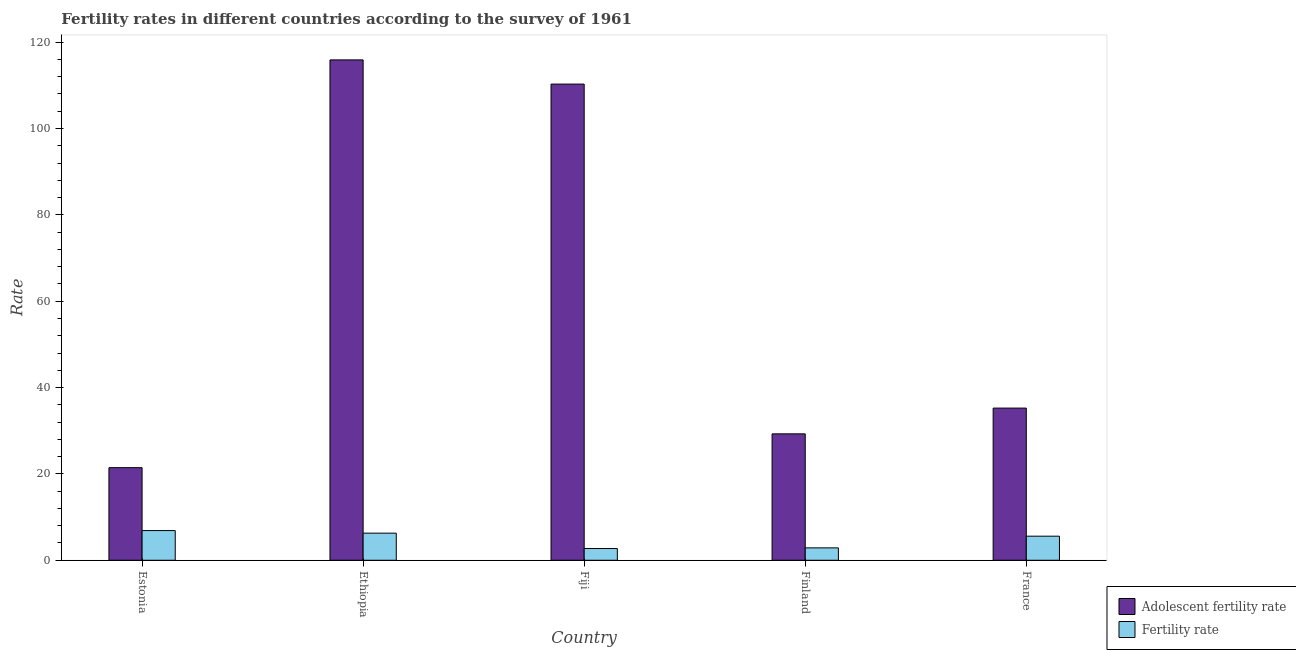How many different coloured bars are there?
Provide a succinct answer. 2. How many groups of bars are there?
Provide a short and direct response. 5. Are the number of bars on each tick of the X-axis equal?
Make the answer very short. Yes. What is the label of the 4th group of bars from the left?
Ensure brevity in your answer.  Finland. What is the fertility rate in France?
Provide a succinct answer. 5.58. Across all countries, what is the maximum adolescent fertility rate?
Offer a very short reply. 115.89. Across all countries, what is the minimum adolescent fertility rate?
Ensure brevity in your answer.  21.45. In which country was the fertility rate maximum?
Give a very brief answer. Estonia. In which country was the fertility rate minimum?
Your response must be concise. Fiji. What is the total adolescent fertility rate in the graph?
Your answer should be compact. 312.15. What is the difference between the adolescent fertility rate in Ethiopia and that in Fiji?
Your answer should be very brief. 5.6. What is the difference between the adolescent fertility rate in Estonia and the fertility rate in France?
Your answer should be very brief. 15.87. What is the average adolescent fertility rate per country?
Ensure brevity in your answer.  62.43. What is the difference between the adolescent fertility rate and fertility rate in Estonia?
Provide a succinct answer. 14.57. What is the ratio of the adolescent fertility rate in Ethiopia to that in Fiji?
Offer a terse response. 1.05. Is the adolescent fertility rate in Fiji less than that in France?
Give a very brief answer. No. Is the difference between the adolescent fertility rate in Ethiopia and Finland greater than the difference between the fertility rate in Ethiopia and Finland?
Provide a short and direct response. Yes. What is the difference between the highest and the second highest fertility rate?
Keep it short and to the point. 0.6. What is the difference between the highest and the lowest fertility rate?
Your response must be concise. 4.16. Is the sum of the adolescent fertility rate in Estonia and Fiji greater than the maximum fertility rate across all countries?
Ensure brevity in your answer.  Yes. What does the 2nd bar from the left in France represents?
Give a very brief answer. Fertility rate. What does the 2nd bar from the right in France represents?
Provide a succinct answer. Adolescent fertility rate. How many bars are there?
Give a very brief answer. 10. How many countries are there in the graph?
Make the answer very short. 5. Are the values on the major ticks of Y-axis written in scientific E-notation?
Offer a very short reply. No. Does the graph contain any zero values?
Provide a succinct answer. No. Does the graph contain grids?
Your response must be concise. No. How many legend labels are there?
Your answer should be compact. 2. What is the title of the graph?
Ensure brevity in your answer.  Fertility rates in different countries according to the survey of 1961. What is the label or title of the X-axis?
Offer a terse response. Country. What is the label or title of the Y-axis?
Your answer should be very brief. Rate. What is the Rate of Adolescent fertility rate in Estonia?
Give a very brief answer. 21.45. What is the Rate of Fertility rate in Estonia?
Give a very brief answer. 6.88. What is the Rate in Adolescent fertility rate in Ethiopia?
Provide a short and direct response. 115.89. What is the Rate in Fertility rate in Ethiopia?
Make the answer very short. 6.28. What is the Rate in Adolescent fertility rate in Fiji?
Your answer should be very brief. 110.29. What is the Rate in Fertility rate in Fiji?
Provide a succinct answer. 2.72. What is the Rate in Adolescent fertility rate in Finland?
Offer a very short reply. 29.28. What is the Rate in Fertility rate in Finland?
Make the answer very short. 2.87. What is the Rate of Adolescent fertility rate in France?
Offer a very short reply. 35.25. What is the Rate of Fertility rate in France?
Offer a terse response. 5.58. Across all countries, what is the maximum Rate of Adolescent fertility rate?
Give a very brief answer. 115.89. Across all countries, what is the maximum Rate in Fertility rate?
Offer a very short reply. 6.88. Across all countries, what is the minimum Rate in Adolescent fertility rate?
Make the answer very short. 21.45. Across all countries, what is the minimum Rate in Fertility rate?
Ensure brevity in your answer.  2.72. What is the total Rate of Adolescent fertility rate in the graph?
Give a very brief answer. 312.15. What is the total Rate in Fertility rate in the graph?
Make the answer very short. 24.32. What is the difference between the Rate of Adolescent fertility rate in Estonia and that in Ethiopia?
Your answer should be compact. -94.44. What is the difference between the Rate in Fertility rate in Estonia and that in Ethiopia?
Offer a very short reply. 0.6. What is the difference between the Rate of Adolescent fertility rate in Estonia and that in Fiji?
Your answer should be very brief. -88.84. What is the difference between the Rate of Fertility rate in Estonia and that in Fiji?
Provide a succinct answer. 4.16. What is the difference between the Rate in Adolescent fertility rate in Estonia and that in Finland?
Provide a short and direct response. -7.83. What is the difference between the Rate in Fertility rate in Estonia and that in Finland?
Offer a very short reply. 4.01. What is the difference between the Rate in Adolescent fertility rate in Estonia and that in France?
Provide a succinct answer. -13.8. What is the difference between the Rate in Fertility rate in Estonia and that in France?
Keep it short and to the point. 1.3. What is the difference between the Rate of Adolescent fertility rate in Ethiopia and that in Fiji?
Make the answer very short. 5.6. What is the difference between the Rate of Fertility rate in Ethiopia and that in Fiji?
Keep it short and to the point. 3.56. What is the difference between the Rate in Adolescent fertility rate in Ethiopia and that in Finland?
Provide a succinct answer. 86.61. What is the difference between the Rate of Fertility rate in Ethiopia and that in Finland?
Offer a very short reply. 3.41. What is the difference between the Rate in Adolescent fertility rate in Ethiopia and that in France?
Give a very brief answer. 80.64. What is the difference between the Rate of Fertility rate in Ethiopia and that in France?
Keep it short and to the point. 0.7. What is the difference between the Rate in Adolescent fertility rate in Fiji and that in Finland?
Your answer should be very brief. 81.01. What is the difference between the Rate in Fertility rate in Fiji and that in Finland?
Keep it short and to the point. -0.15. What is the difference between the Rate in Adolescent fertility rate in Fiji and that in France?
Give a very brief answer. 75.04. What is the difference between the Rate of Fertility rate in Fiji and that in France?
Offer a very short reply. -2.86. What is the difference between the Rate of Adolescent fertility rate in Finland and that in France?
Make the answer very short. -5.97. What is the difference between the Rate in Fertility rate in Finland and that in France?
Give a very brief answer. -2.71. What is the difference between the Rate of Adolescent fertility rate in Estonia and the Rate of Fertility rate in Ethiopia?
Your answer should be very brief. 15.17. What is the difference between the Rate in Adolescent fertility rate in Estonia and the Rate in Fertility rate in Fiji?
Your answer should be very brief. 18.73. What is the difference between the Rate in Adolescent fertility rate in Estonia and the Rate in Fertility rate in Finland?
Offer a terse response. 18.58. What is the difference between the Rate in Adolescent fertility rate in Estonia and the Rate in Fertility rate in France?
Ensure brevity in your answer.  15.87. What is the difference between the Rate of Adolescent fertility rate in Ethiopia and the Rate of Fertility rate in Fiji?
Your answer should be very brief. 113.17. What is the difference between the Rate in Adolescent fertility rate in Ethiopia and the Rate in Fertility rate in Finland?
Your answer should be very brief. 113.02. What is the difference between the Rate in Adolescent fertility rate in Ethiopia and the Rate in Fertility rate in France?
Make the answer very short. 110.31. What is the difference between the Rate of Adolescent fertility rate in Fiji and the Rate of Fertility rate in Finland?
Keep it short and to the point. 107.42. What is the difference between the Rate of Adolescent fertility rate in Fiji and the Rate of Fertility rate in France?
Offer a very short reply. 104.71. What is the difference between the Rate in Adolescent fertility rate in Finland and the Rate in Fertility rate in France?
Keep it short and to the point. 23.7. What is the average Rate of Adolescent fertility rate per country?
Give a very brief answer. 62.43. What is the average Rate in Fertility rate per country?
Give a very brief answer. 4.87. What is the difference between the Rate in Adolescent fertility rate and Rate in Fertility rate in Estonia?
Your answer should be compact. 14.57. What is the difference between the Rate in Adolescent fertility rate and Rate in Fertility rate in Ethiopia?
Provide a succinct answer. 109.61. What is the difference between the Rate in Adolescent fertility rate and Rate in Fertility rate in Fiji?
Offer a very short reply. 107.57. What is the difference between the Rate in Adolescent fertility rate and Rate in Fertility rate in Finland?
Your response must be concise. 26.41. What is the difference between the Rate of Adolescent fertility rate and Rate of Fertility rate in France?
Offer a terse response. 29.67. What is the ratio of the Rate of Adolescent fertility rate in Estonia to that in Ethiopia?
Your response must be concise. 0.19. What is the ratio of the Rate in Fertility rate in Estonia to that in Ethiopia?
Keep it short and to the point. 1.09. What is the ratio of the Rate in Adolescent fertility rate in Estonia to that in Fiji?
Provide a short and direct response. 0.19. What is the ratio of the Rate of Fertility rate in Estonia to that in Fiji?
Your response must be concise. 2.53. What is the ratio of the Rate of Adolescent fertility rate in Estonia to that in Finland?
Offer a terse response. 0.73. What is the ratio of the Rate in Fertility rate in Estonia to that in Finland?
Give a very brief answer. 2.4. What is the ratio of the Rate in Adolescent fertility rate in Estonia to that in France?
Provide a short and direct response. 0.61. What is the ratio of the Rate of Fertility rate in Estonia to that in France?
Offer a very short reply. 1.23. What is the ratio of the Rate in Adolescent fertility rate in Ethiopia to that in Fiji?
Keep it short and to the point. 1.05. What is the ratio of the Rate of Fertility rate in Ethiopia to that in Fiji?
Your response must be concise. 2.31. What is the ratio of the Rate of Adolescent fertility rate in Ethiopia to that in Finland?
Offer a very short reply. 3.96. What is the ratio of the Rate in Fertility rate in Ethiopia to that in Finland?
Your response must be concise. 2.19. What is the ratio of the Rate in Adolescent fertility rate in Ethiopia to that in France?
Offer a very short reply. 3.29. What is the ratio of the Rate in Fertility rate in Ethiopia to that in France?
Your answer should be very brief. 1.13. What is the ratio of the Rate of Adolescent fertility rate in Fiji to that in Finland?
Offer a very short reply. 3.77. What is the ratio of the Rate of Fertility rate in Fiji to that in Finland?
Provide a short and direct response. 0.95. What is the ratio of the Rate in Adolescent fertility rate in Fiji to that in France?
Ensure brevity in your answer.  3.13. What is the ratio of the Rate of Fertility rate in Fiji to that in France?
Offer a terse response. 0.49. What is the ratio of the Rate of Adolescent fertility rate in Finland to that in France?
Give a very brief answer. 0.83. What is the ratio of the Rate of Fertility rate in Finland to that in France?
Provide a succinct answer. 0.51. What is the difference between the highest and the second highest Rate in Adolescent fertility rate?
Provide a short and direct response. 5.6. What is the difference between the highest and the second highest Rate of Fertility rate?
Your response must be concise. 0.6. What is the difference between the highest and the lowest Rate of Adolescent fertility rate?
Ensure brevity in your answer.  94.44. What is the difference between the highest and the lowest Rate of Fertility rate?
Provide a succinct answer. 4.16. 